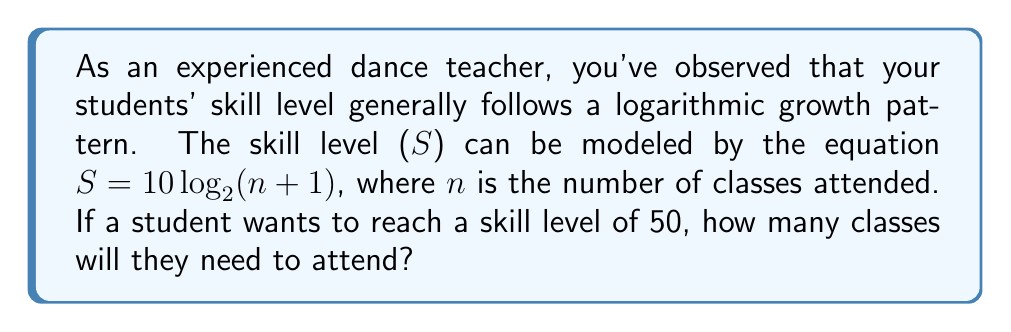Can you solve this math problem? To solve this problem, we need to use the given logarithmic equation and solve for n:

1) We start with the equation: $S = 10 \log_2(n + 1)$

2) We know the desired skill level S = 50, so we substitute this:
   $50 = 10 \log_2(n + 1)$

3) Divide both sides by 10:
   $5 = \log_2(n + 1)$

4) To solve for n, we need to apply the inverse function (exponential) to both sides:
   $2^5 = 2^{\log_2(n + 1)}$

5) Simplify the left side:
   $32 = n + 1$

6) Subtract 1 from both sides:
   $31 = n$

7) Therefore, the student needs to attend 31 classes to reach a skill level of 50.

This logarithmic model reflects the reality of skill acquisition in dance, where progress is rapid at first but then slows down as the student approaches higher skill levels. As a dance teacher, understanding this pattern can help in setting realistic expectations and planning long-term student development.
Answer: 31 classes 